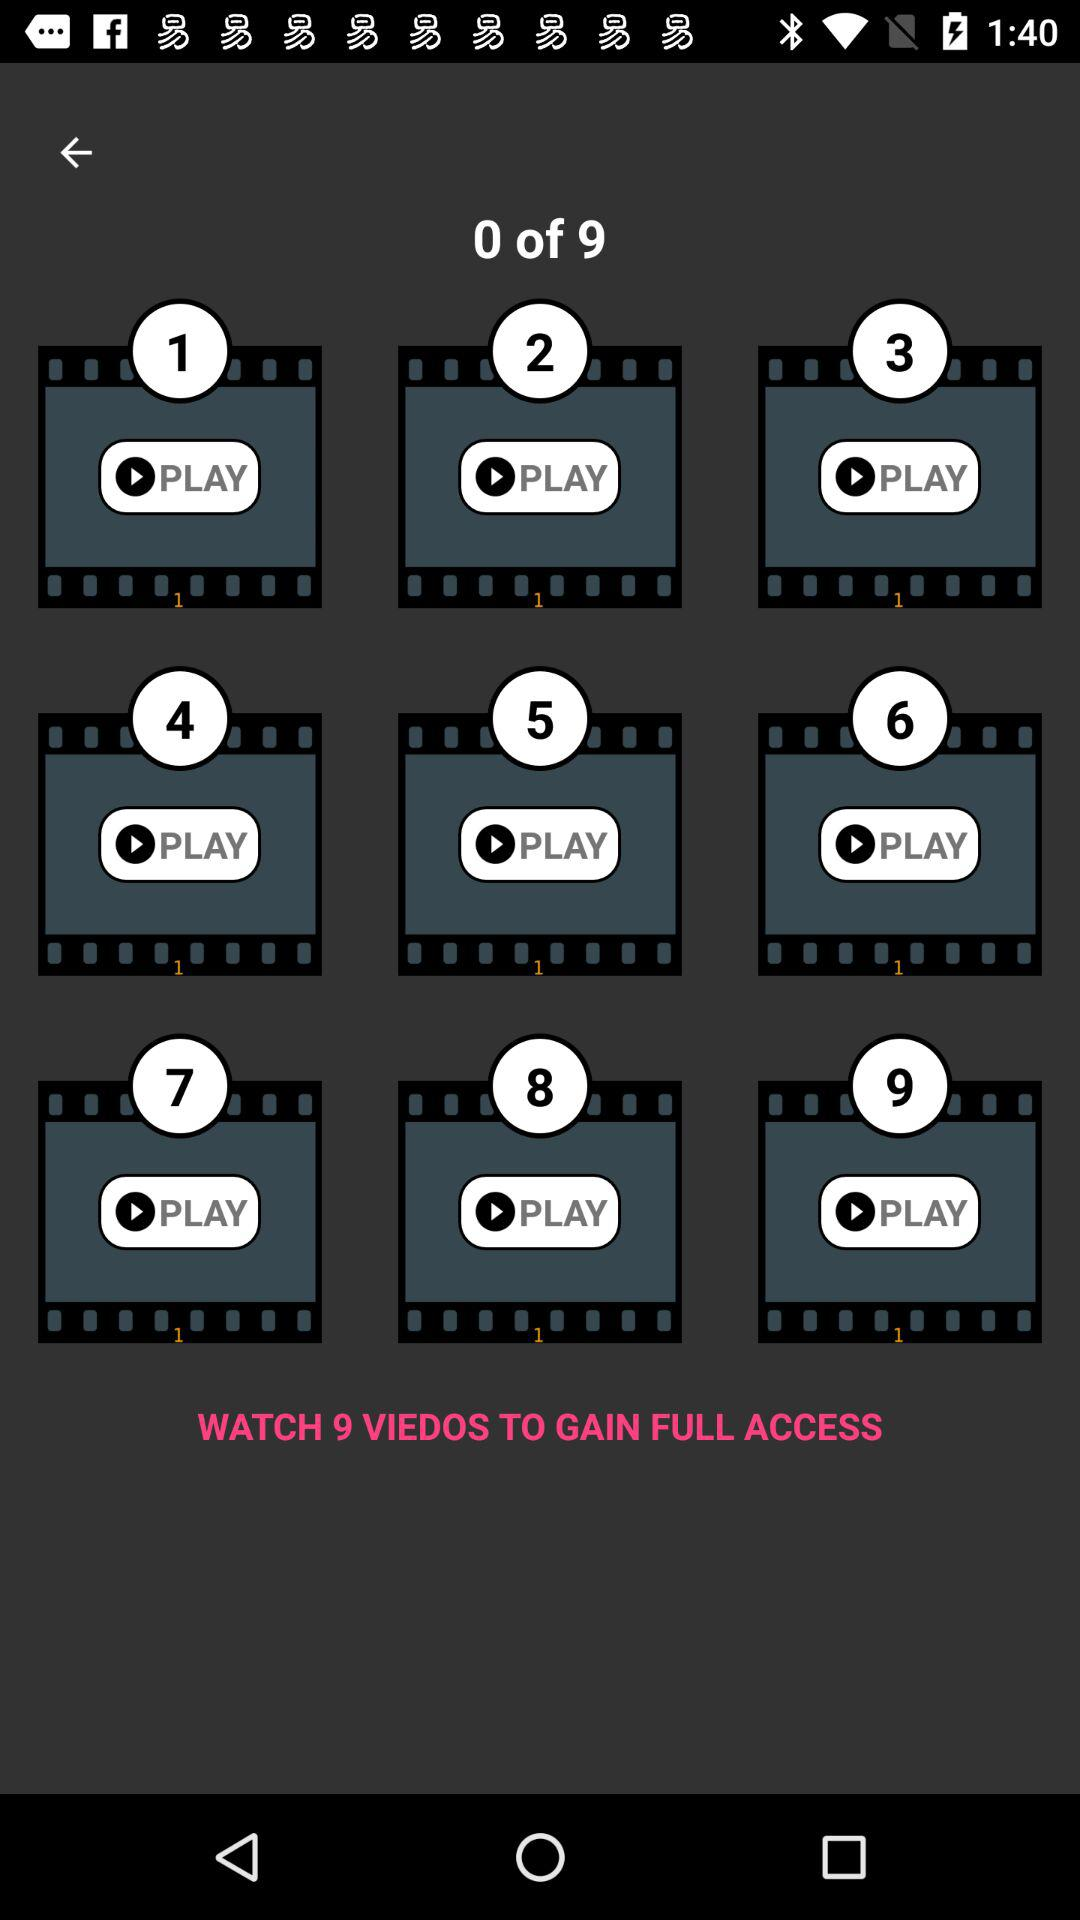How many videos have you watched?
Answer the question using a single word or phrase. 0 